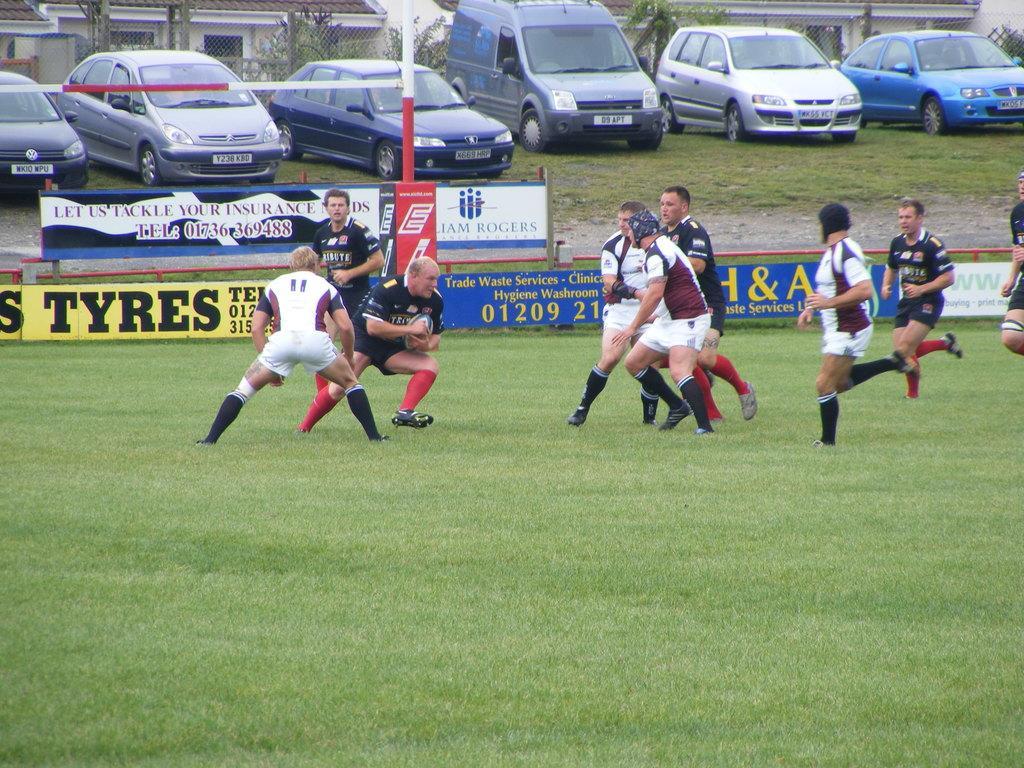Please provide a concise description of this image. In this image I can see group of people playing game. The person in front white color dress, background I can see a board attached to the pole, the board is in blue and yellow color. I can also see few cars and building in white color. 